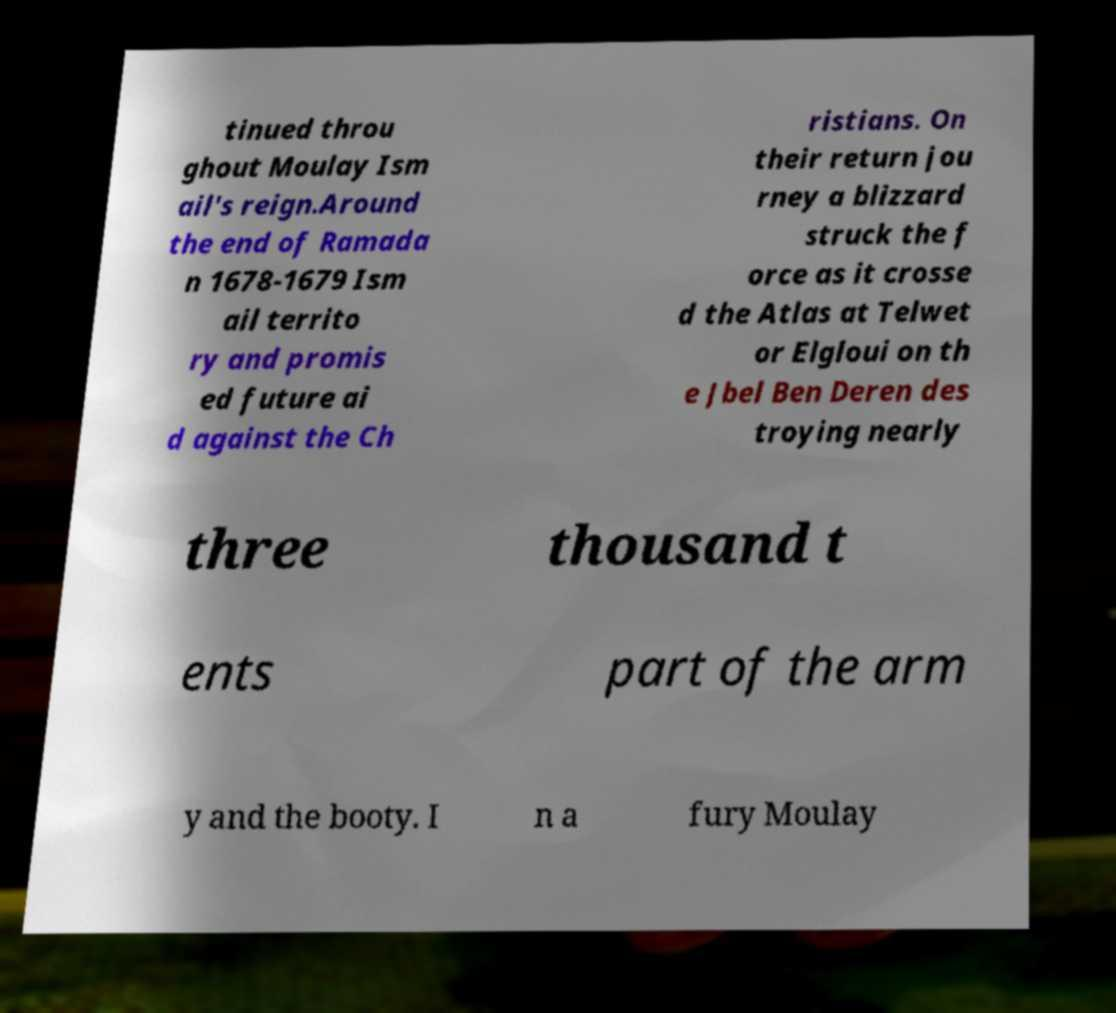Can you accurately transcribe the text from the provided image for me? tinued throu ghout Moulay Ism ail's reign.Around the end of Ramada n 1678-1679 Ism ail territo ry and promis ed future ai d against the Ch ristians. On their return jou rney a blizzard struck the f orce as it crosse d the Atlas at Telwet or Elgloui on th e Jbel Ben Deren des troying nearly three thousand t ents part of the arm y and the booty. I n a fury Moulay 